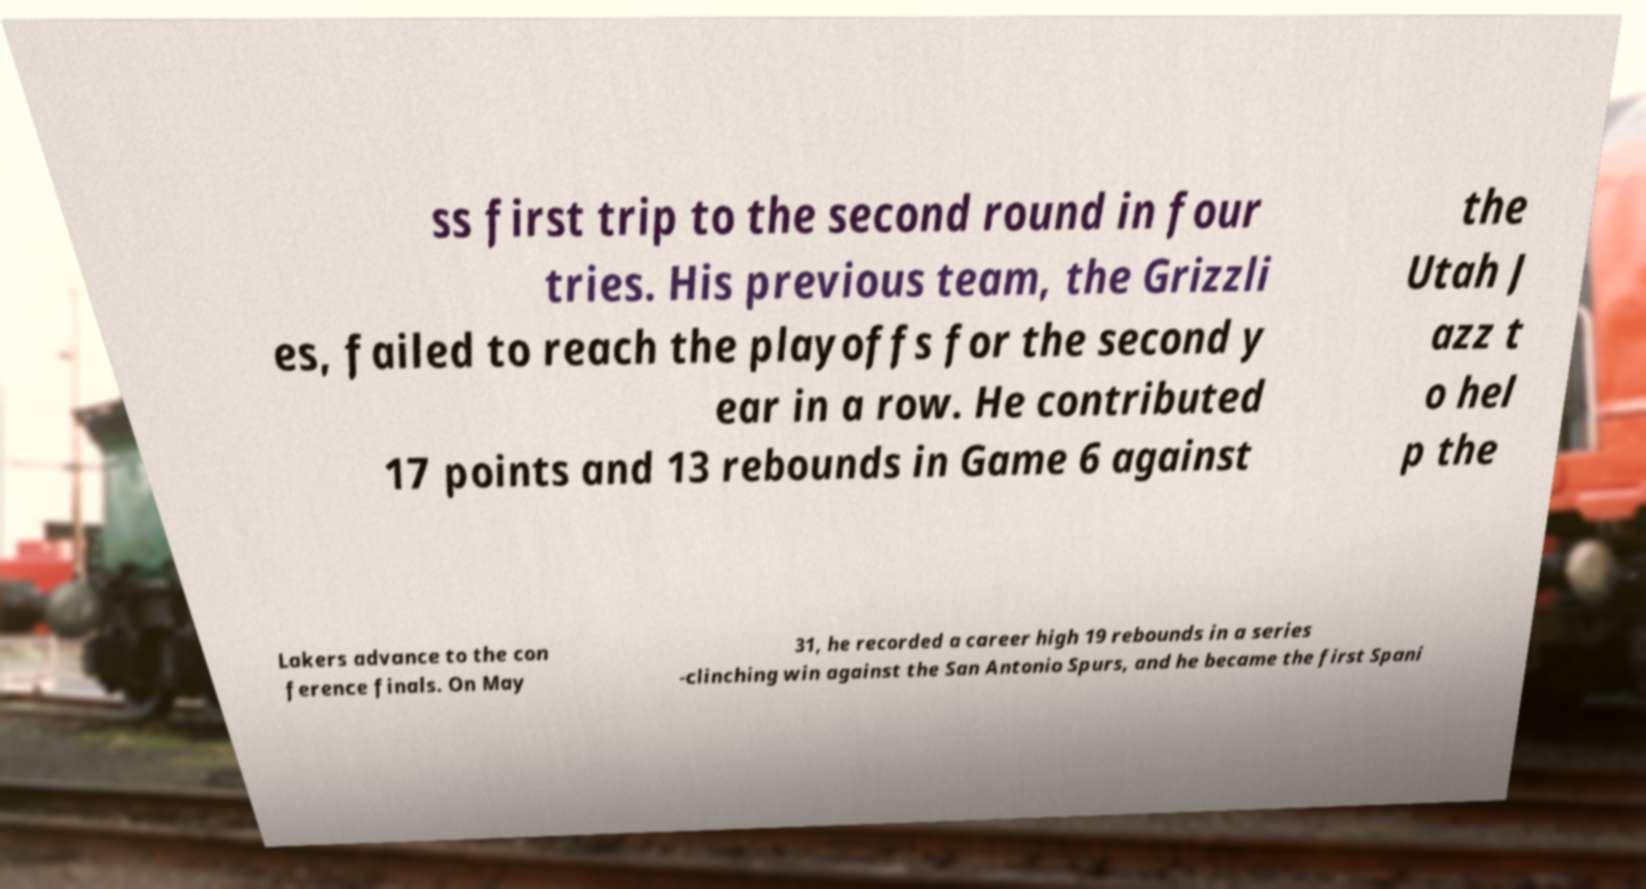Can you read and provide the text displayed in the image?This photo seems to have some interesting text. Can you extract and type it out for me? ss first trip to the second round in four tries. His previous team, the Grizzli es, failed to reach the playoffs for the second y ear in a row. He contributed 17 points and 13 rebounds in Game 6 against the Utah J azz t o hel p the Lakers advance to the con ference finals. On May 31, he recorded a career high 19 rebounds in a series -clinching win against the San Antonio Spurs, and he became the first Spani 